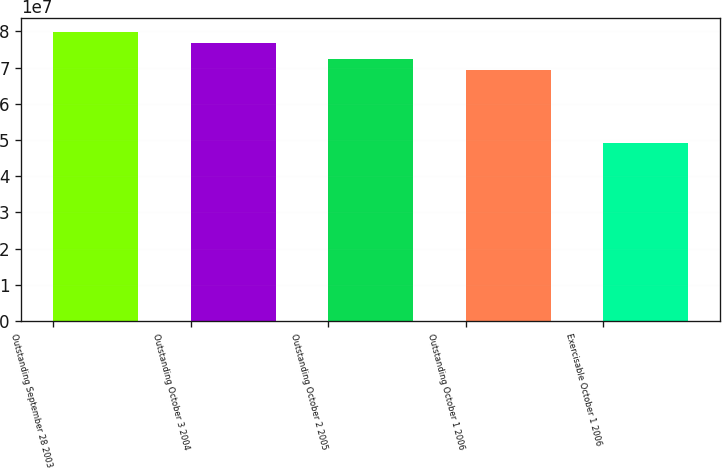Convert chart to OTSL. <chart><loc_0><loc_0><loc_500><loc_500><bar_chart><fcel>Outstanding September 28 2003<fcel>Outstanding October 3 2004<fcel>Outstanding October 2 2005<fcel>Outstanding October 1 2006<fcel>Exercisable October 1 2006<nl><fcel>7.9726e+07<fcel>7.68332e+07<fcel>7.24589e+07<fcel>6.94199e+07<fcel>4.92033e+07<nl></chart> 